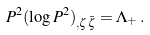<formula> <loc_0><loc_0><loc_500><loc_500>P ^ { 2 } ( \log P ^ { 2 } ) _ { , \zeta \bar { \zeta } } = \Lambda _ { + } \, .</formula> 